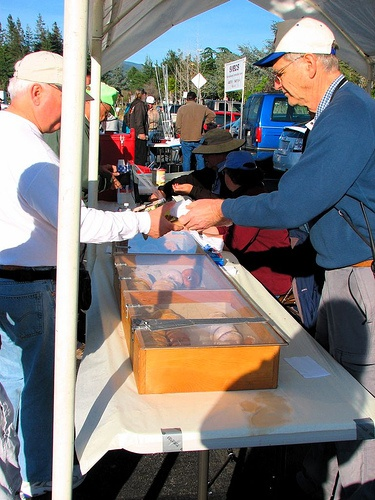Describe the objects in this image and their specific colors. I can see dining table in lightblue, ivory, gray, darkgray, and orange tones, people in lightblue, white, black, navy, and gray tones, people in lightblue, blue, black, and darkgray tones, people in lightblue, black, maroon, brown, and navy tones, and car in lightblue, blue, black, and navy tones in this image. 